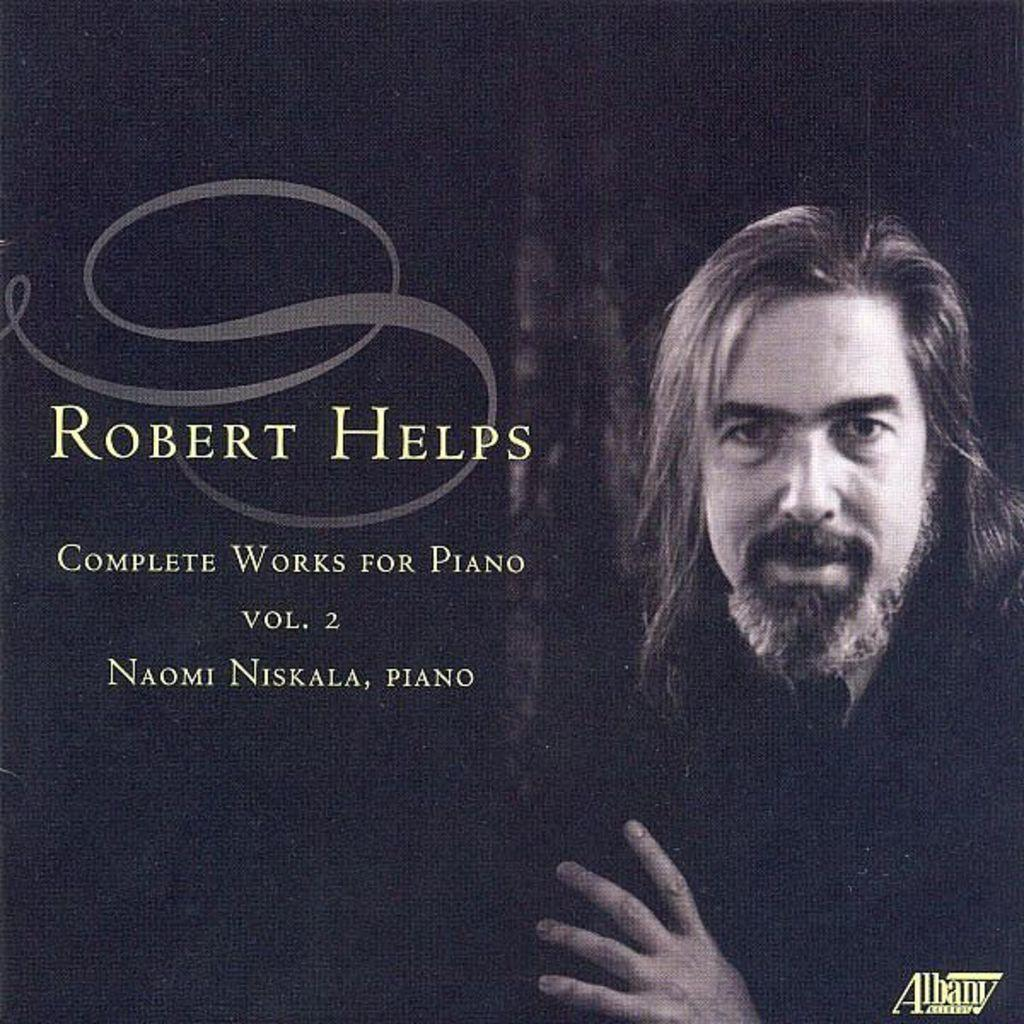What is located on the right side of the image? There is a person on the right side of the image. What can be seen on the left side of the image? There is some text on the left side of the image. How many clovers are present in the image? There are no clovers visible in the image. What type of spark can be seen coming from the person in the image? There is no spark present in the image; the person is not depicted as emitting any sparks. 